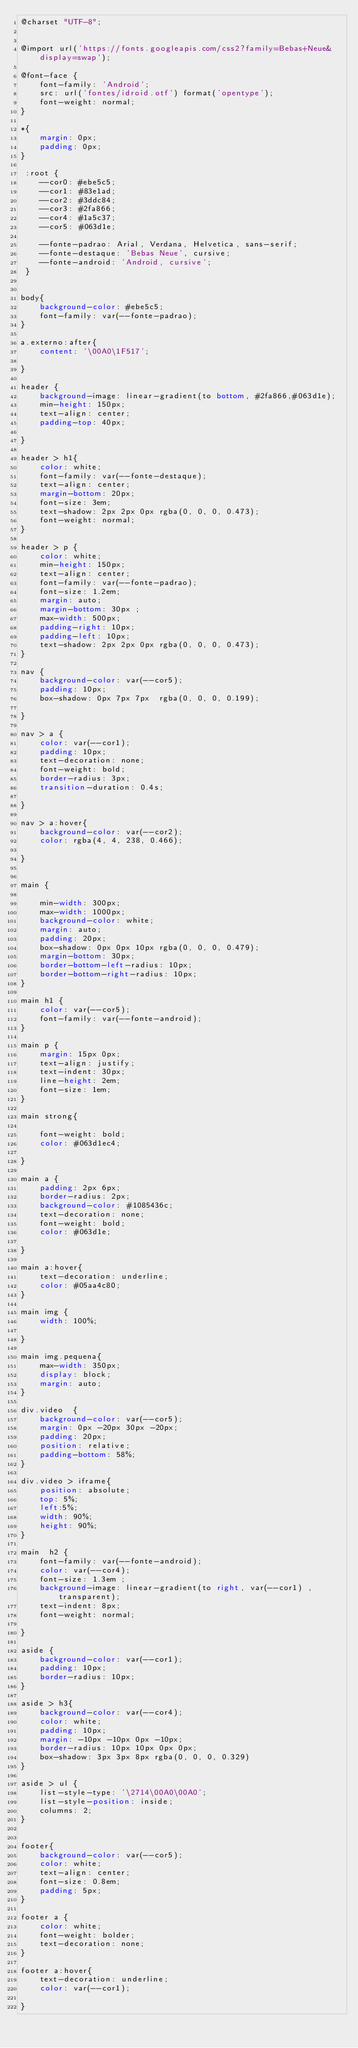Convert code to text. <code><loc_0><loc_0><loc_500><loc_500><_CSS_>@charset "UTF-8";


@import url('https://fonts.googleapis.com/css2?family=Bebas+Neue&display=swap');

@font-face {
    font-family: 'Android';
    src: url('fontes/idroid.otf') format('opentype');
    font-weight: normal;
}

*{
    margin: 0px;
    padding: 0px;
}

 :root {
    --cor0: #ebe5c5;
    --cor1: #83e1ad; 
    --cor2: #3ddc84;
    --cor3: #2fa866;
    --cor4: #1a5c37;
    --cor5: #063d1e;

    --fonte-padrao: Arial, Verdana, Helvetica, sans-serif;
    --fonte-destaque: 'Bebas Neue', cursive;
    --fonte-android: 'Android, cursive';
 }


body{
    background-color: #ebe5c5;
    font-family: var(--fonte-padrao);
}

a.externo:after{
    content: '\00A0\1F517';

}

header {
    background-image: linear-gradient(to bottom, #2fa866,#063d1e);
    min-height: 150px;
    text-align: center;
    padding-top: 40px;

}

header > h1{
    color: white;
    font-family: var(--fonte-destaque);
    text-align: center;
    margin-bottom: 20px;
    font-size: 3em;
    text-shadow: 2px 2px 0px rgba(0, 0, 0, 0.473);
    font-weight: normal;
}

header > p {
    color: white;
    min-height: 150px;
    text-align: center;
    font-family: var(--fonte-padrao);
    font-size: 1.2em;
    margin: auto;
    margin-bottom: 30px ;
    max-width: 500px;
    padding-right: 10px;
    padding-left: 10px;
    text-shadow: 2px 2px 0px rgba(0, 0, 0, 0.473);
}

nav {
    background-color: var(--cor5);
    padding: 10px;
    box-shadow: 0px 7px 7px  rgba(0, 0, 0, 0.199);
    
}

nav > a {
    color: var(--cor1);
    padding: 10px;
    text-decoration: none;
    font-weight: bold;
    border-radius: 3px;
    transition-duration: 0.4s;
    
}

nav > a:hover{
    background-color: var(--cor2);
    color: rgba(4, 4, 238, 0.466);

}


main {

    min-width: 300px;
    max-width: 1000px;
    background-color: white;
    margin: auto;
    padding: 20px;
    box-shadow: 0px 0px 10px rgba(0, 0, 0, 0.479);
    margin-bottom: 30px;
    border-bottom-left-radius: 10px;
    border-bottom-right-radius: 10px;
}

main h1 {
    color: var(--cor5);
    font-family: var(--fonte-android);
}

main p {
    margin: 15px 0px;
    text-align: justify;
    text-indent: 30px;
    line-height: 2em;
    font-size: 1em;
}

main strong{
    
    font-weight: bold;
    color: #063d1ec4;
    
}

main a {
    padding: 2px 6px;
    border-radius: 2px;
    background-color: #1085436c;
    text-decoration: none;
    font-weight: bold;
    color: #063d1e;

}

main a:hover{
    text-decoration: underline;
    color: #05aa4c80;
}

main img {
    width: 100%;
    
}

main img.pequena{
    max-width: 350px;
    display: block;
    margin: auto;
}

div.video  {
    background-color: var(--cor5);
    margin: 0px -20px 30px -20px;
    padding: 20px;
    position: relative;
    padding-bottom: 58%;
}

div.video > iframe{
    position: absolute;
    top: 5%;
    left:5%;
    width: 90%;
    height: 90%;
}

main  h2 {
    font-family: var(--fonte-android);
    color: var(--cor4);
    font-size: 1.3em ;
    background-image: linear-gradient(to right, var(--cor1) , transparent);
    text-indent: 8px;
    font-weight: normal;

}

aside {
    background-color: var(--cor1);
    padding: 10px;
    border-radius: 10px;
}

aside > h3{
    background-color: var(--cor4);
    color: white;     
    padding: 10px;
    margin: -10px -10px 0px -10px;
    border-radius: 10px 10px 0px 0px;
    box-shadow: 3px 3px 8px rgba(0, 0, 0, 0.329)
}

aside > ul {
    list-style-type: '\2714\00A0\00A0';
    list-style-position: inside;
    columns: 2;
}


footer{
    background-color: var(--cor5);
    color: white;
    text-align: center;
    font-size: 0.8em;
    padding: 5px;
}

footer a {
    color: white;
    font-weight: bolder;
    text-decoration: none;
}

footer a:hover{
    text-decoration: underline;
    color: var(--cor1);

}</code> 